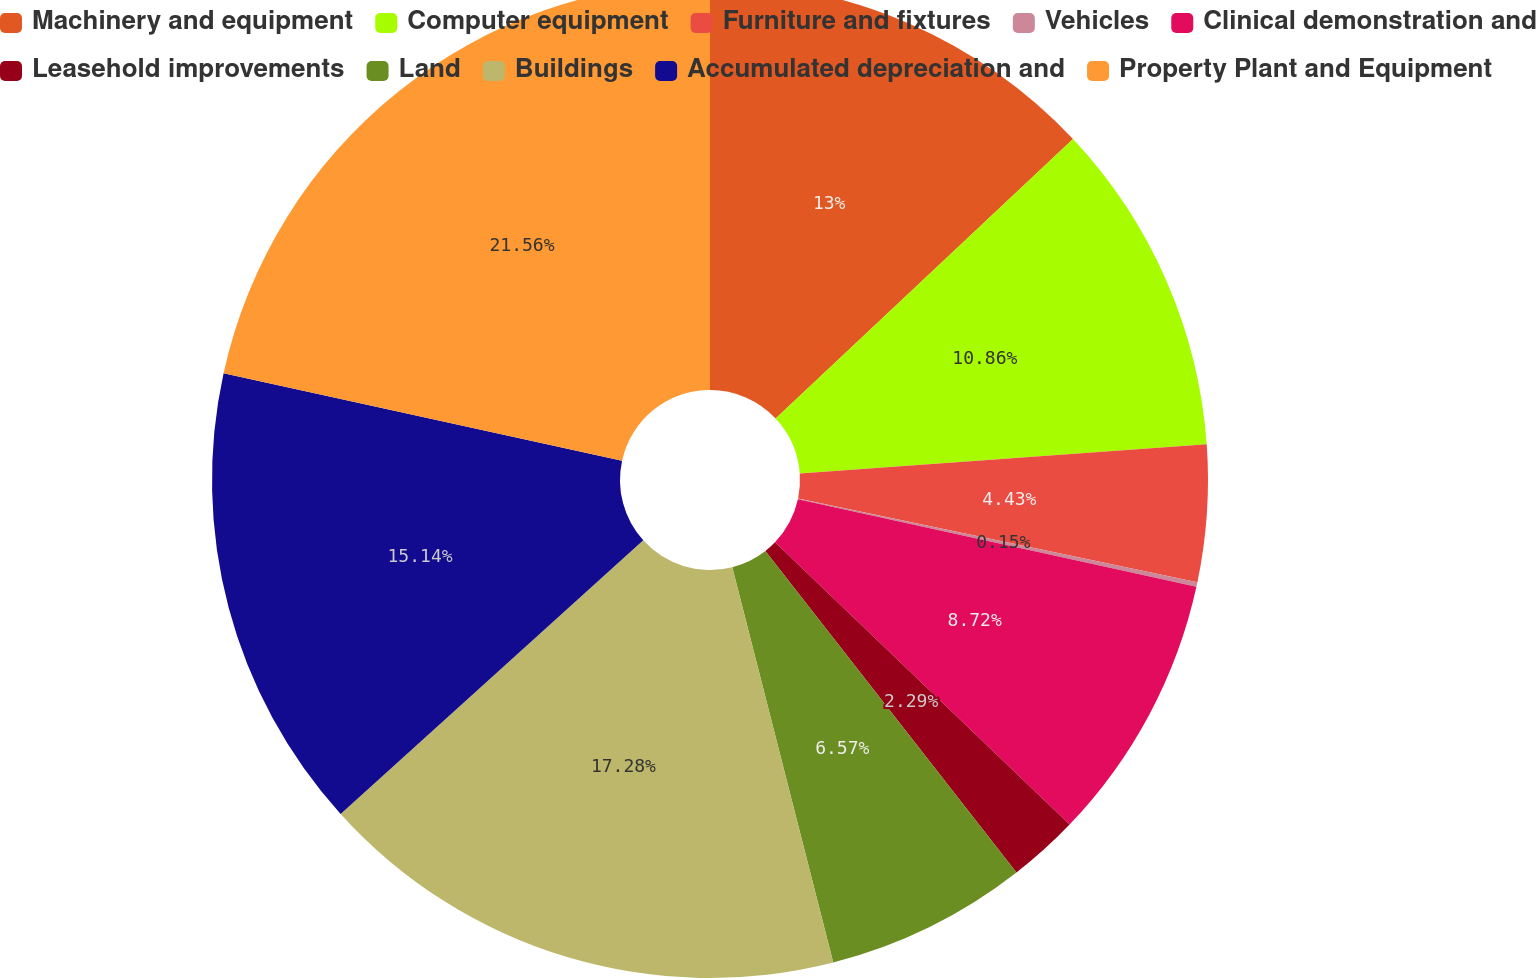Convert chart. <chart><loc_0><loc_0><loc_500><loc_500><pie_chart><fcel>Machinery and equipment<fcel>Computer equipment<fcel>Furniture and fixtures<fcel>Vehicles<fcel>Clinical demonstration and<fcel>Leasehold improvements<fcel>Land<fcel>Buildings<fcel>Accumulated depreciation and<fcel>Property Plant and Equipment<nl><fcel>13.0%<fcel>10.86%<fcel>4.43%<fcel>0.15%<fcel>8.72%<fcel>2.29%<fcel>6.57%<fcel>17.28%<fcel>15.14%<fcel>21.56%<nl></chart> 